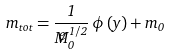<formula> <loc_0><loc_0><loc_500><loc_500>m _ { t o t } = \frac { 1 } { { \widetilde { M } } _ { 0 } ^ { 1 / 2 } } \, \phi \left ( y \right ) + m _ { 0 }</formula> 